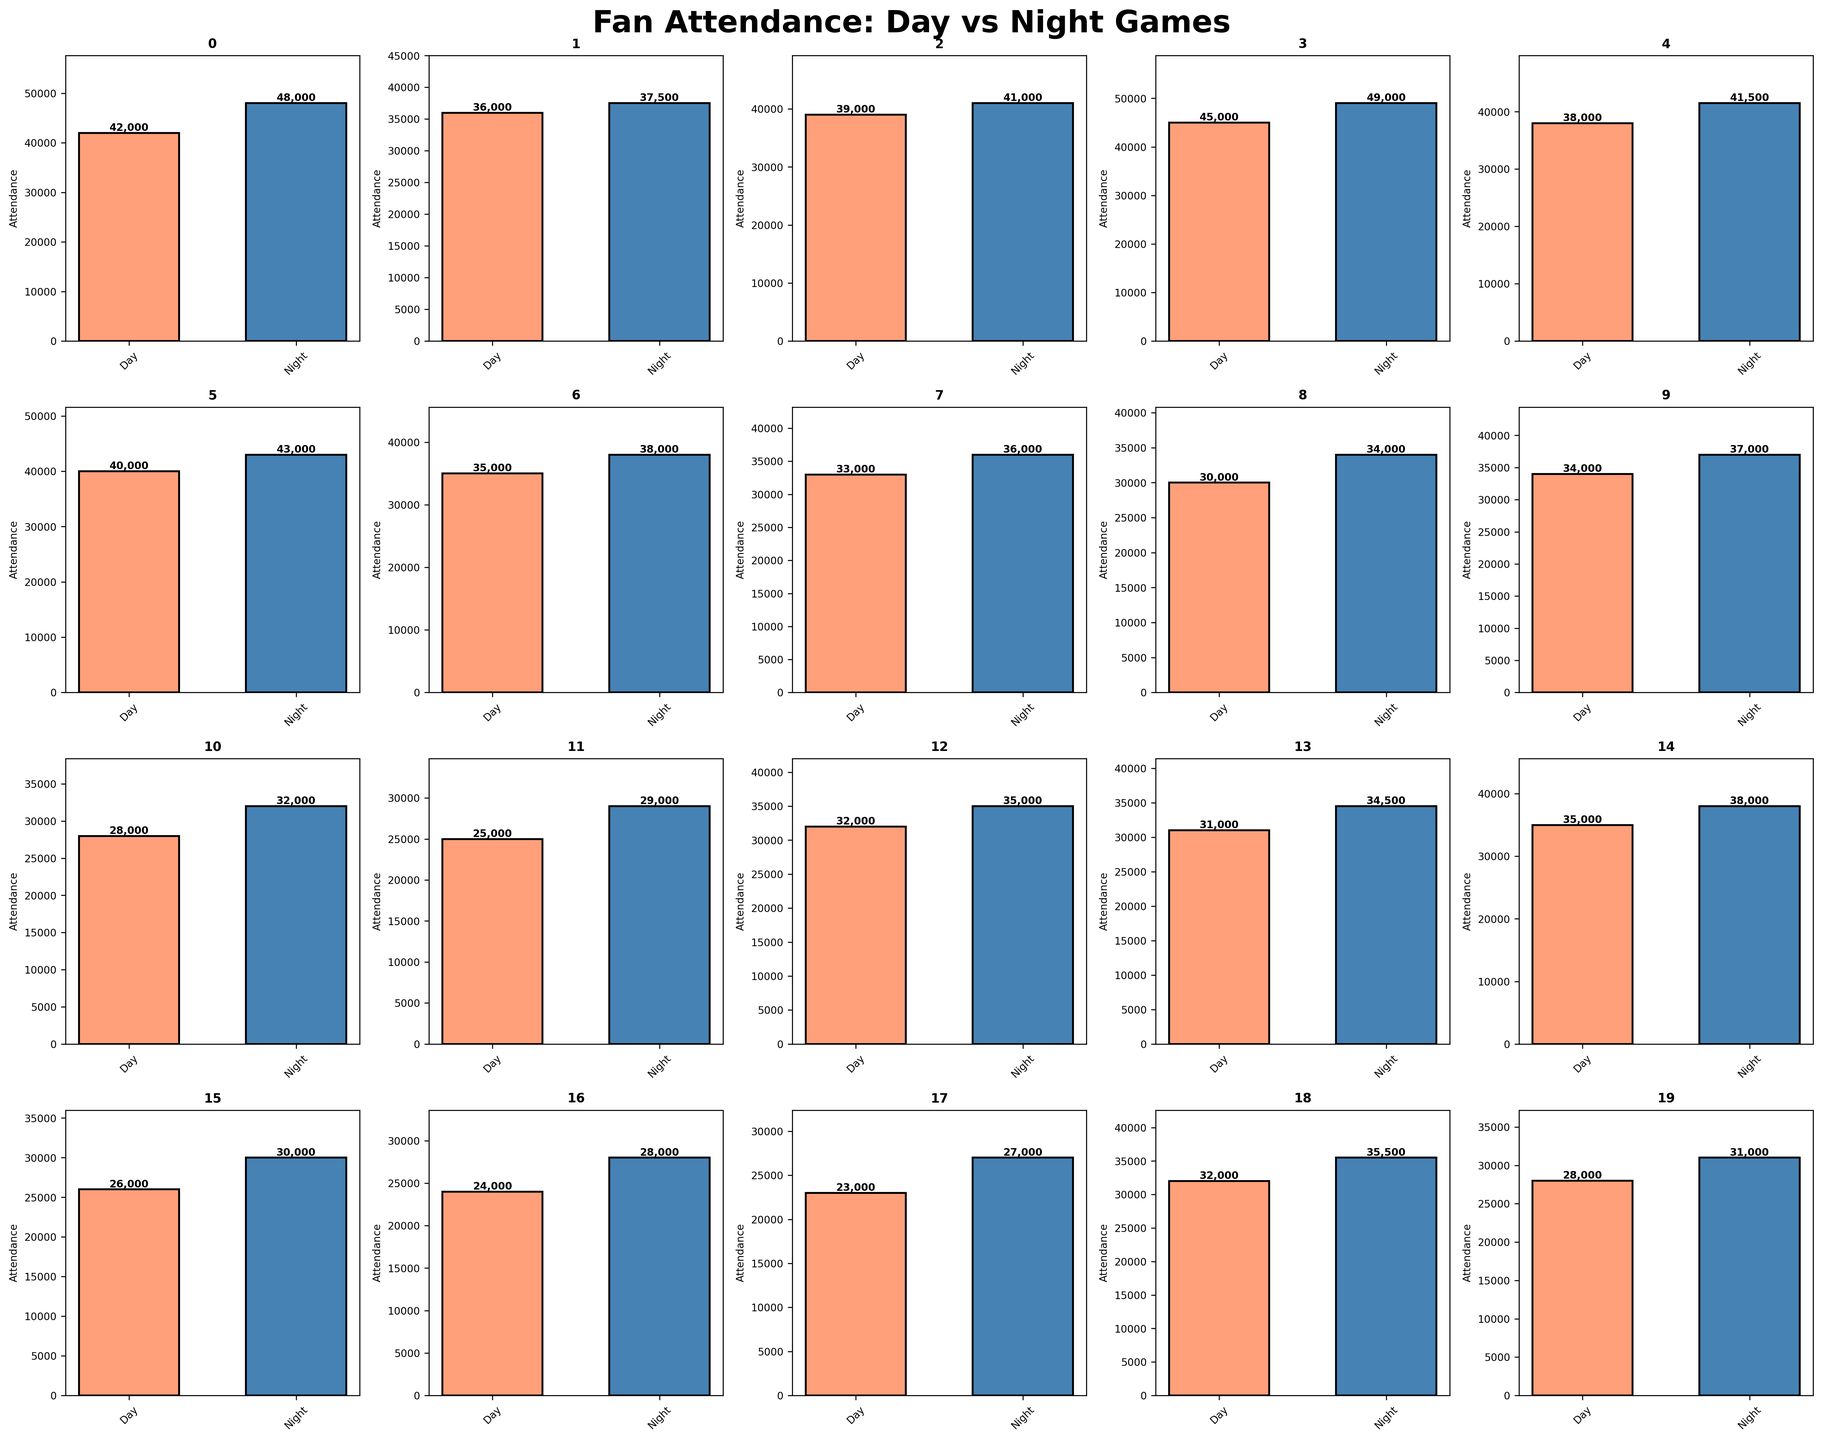Which stadium has the highest night game attendance? First, locate the bar representing night game attendance for Dodger Stadium. It is the tallest among all night game bars.
Answer: Dodger Stadium Which stadium shows a smaller difference between day and night game attendance? By observing the height difference between the day and night game bars, Fenway Park appears to have the smallest gap.
Answer: Fenway Park Which stadium has the lowest attendance for day games? Identify the shortest bar representing day game attendance, which is at Great American Ball Park.
Answer: Great American Ball Park What's the average attendance of day games at Yankee Stadium and Fenway Park? Add the day game attendances of Yankee Stadium (42,000) and Fenway Park (36,000), then divide by 2. So, (42,000 + 36,000) / 2 = 39,000.
Answer: 39,000 What is the median attendance for night games across the listed stadiums? Arrange the night game attendance figures in numerical order and identify the middle value: 28000, 29000, 30000, 31000, 32000, 32000, 34000, 34500, 35000, 35500, 36000, 37000, 37500, 38000, 38000, 41000, 41500, 43000, 48000, 49000. The middle values are 35,000 and 36,000, so (35000 + 36000) / 2 = 35,500.
Answer: 35,500 Which stadium has the highest day game attendance that is also higher than its night game attendance? Check each stadium where the day game bar is taller than the night game bar; none meet this criterion.
Answer: None What is the total attendance for night games at Oracle Park, Busch Stadium, and Minute Maid Park combined? Sum the night game attendance for Oracle Park (41,500), Busch Stadium (43,000), and Minute Maid Park (38,000). So, 41,500 + 43,000 + 38,000 = 122,500.
Answer: 122,500 Which stadium has bars with the greatest difference in attendance between day and night games? Calculate the absolute difference between day and night game attendance for each stadium and find the maximum. For Dodger Stadium, the difference is 49,000 - 45,000 = 4,000, which is the highest observed.
Answer: Dodger Stadium How many stadiums have day game attendance below 35,000? Count the bars representing day game attendances below 35,000: Minute Maid Park, Petco Park, T-Mobile Park, Citi Field, Camden Yards, PNC Park, Truist Park, Rogers Centre, Progressive Field, Comerica Park, and Great American Ball Park.
Answer: 11 Which stadium has its lowest attendance value (day or night) being higher than the highest day game attendance value among the lowest three day game attendance stadiums? First, identify the stadiums with the three lowest day game attendances: Progressive Field, Comerica Park, and Great American Ball Park. The highest of these three is Comerica Park with 26,000. The Yankee Stadium’s day game attendance 42,000 is the highest, thus its lowest (42,000) is higher.
Answer: Yankee Stadium 